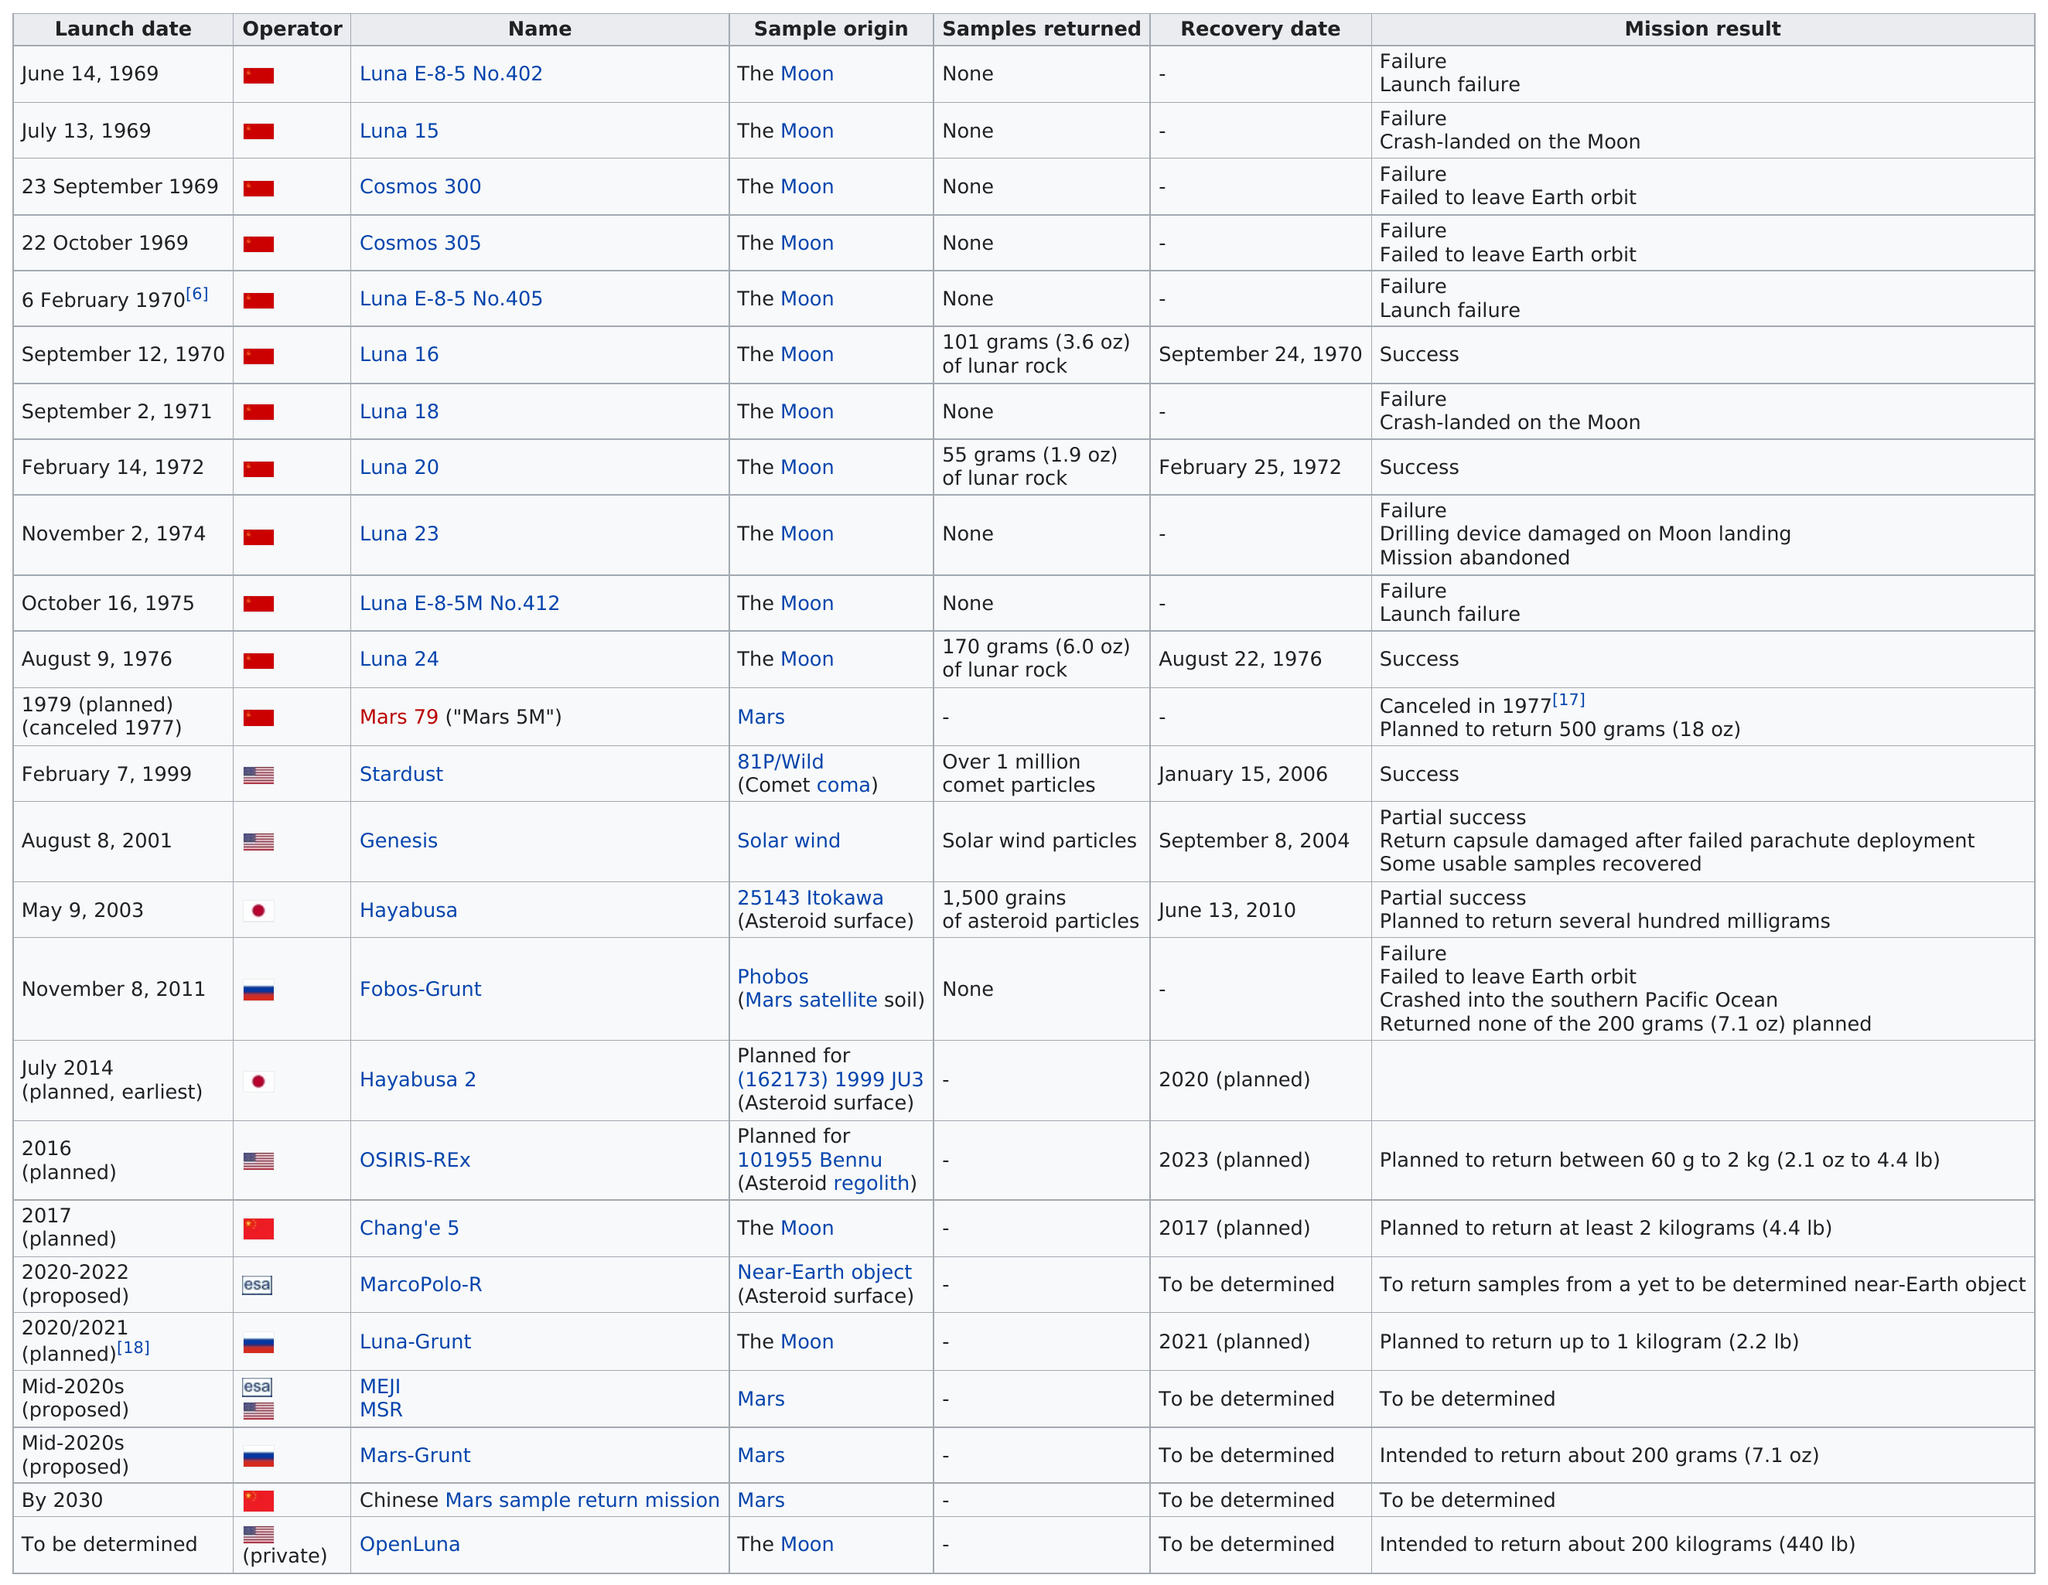Give some essential details in this illustration. Six missions have successfully returned samples. There were 1 failure for the Cosmos 305. The number of missions that returned a sample is 6. In 1970, the first successful use of the technology was recorded. The average number of successful missions was 4. 